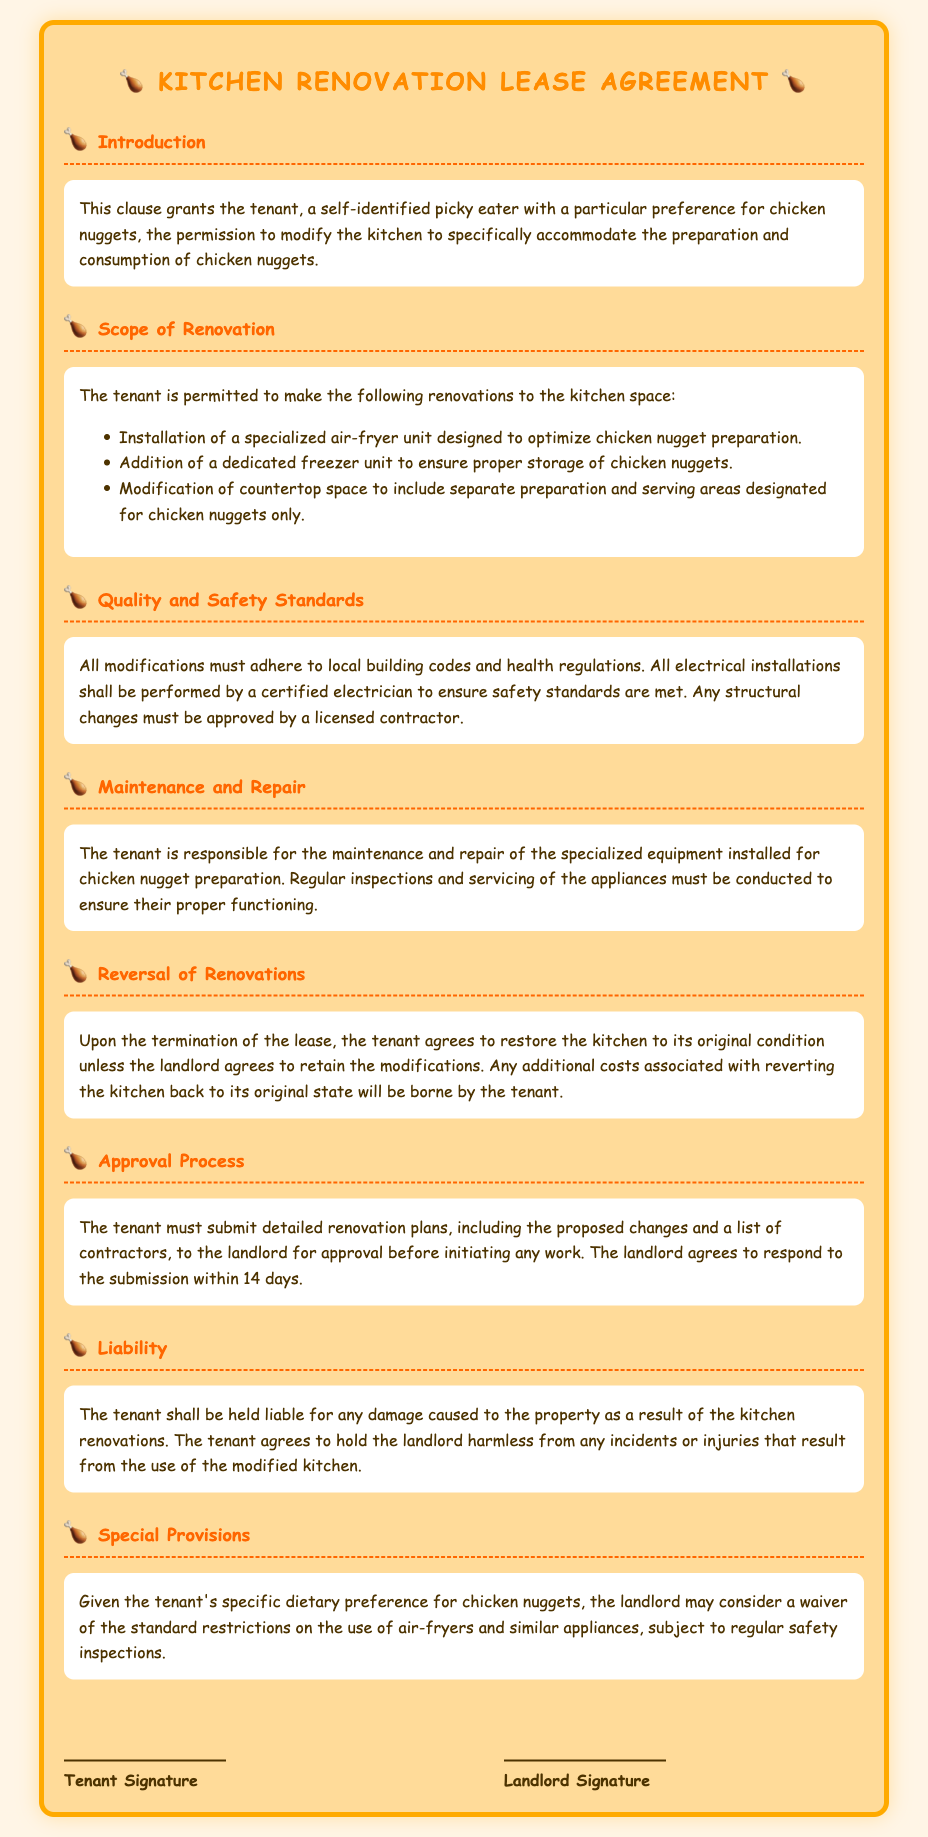What is the main dietary preference of the tenant? The document states that the tenant is a self-identified picky eater with a particular preference for chicken nuggets.
Answer: chicken nuggets What type of appliance is specifically mentioned for chicken nugget preparation? The document lists a specialized air-fryer unit as one of the permitted renovations for chicken nugget preparation.
Answer: air-fryer What must modifications comply with according to the Quality and Safety Standards? It is stated that all modifications must adhere to local building codes and health regulations as per the Quality and Safety Standards section.
Answer: local building codes and health regulations How many days does the landlord have to respond to renovation plans? The document specifies that the landlord agrees to respond to the tenant's submission of renovation plans within 14 days.
Answer: 14 days Who is responsible for the maintenance and repair of the specialized equipment? The document indicates that the tenant is responsible for the maintenance and repair of the specialized equipment installed for chicken nugget preparation.
Answer: tenant What happens upon the termination of the lease regarding kitchen restoration? It is stated that the tenant agrees to restore the kitchen to its original condition unless the landlord agrees to retain the modifications.
Answer: restore to original condition What type of liability does the tenant have regarding kitchen renovations? The document outlines that the tenant shall be held liable for any damage caused to the property as a result of the kitchen renovations.
Answer: liable for damage What is the purpose of the Special Provisions section? The Special Provisions section considers a waiver of standard restrictions on appliances for the tenant’s specific dietary preference for chicken nuggets.
Answer: waiver of standard restrictions What is required before the tenant initiates any work on renovations? The document mentions that the tenant must submit detailed renovation plans to the landlord for approval before initiating any work.
Answer: submit detailed renovation plans 